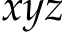Convert formula to latex. <formula><loc_0><loc_0><loc_500><loc_500>x y z</formula> 